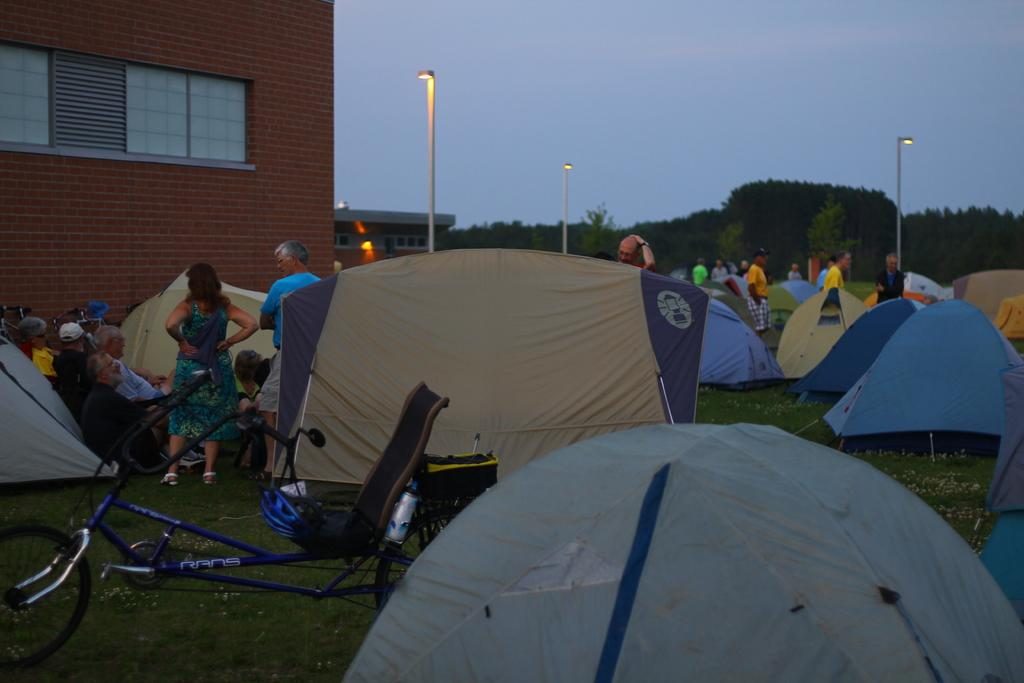How many people are in the image? There are people in the image, but the exact number is not specified. What are some of the people doing in the image? Some of the people are sitting in the image. What type of structures can be seen in the image? There are light poles, tents, and houses in the image. What type of vegetation is present in the image? There are trees in the image. What type of transportation is visible in the image? There is a bicycle in the image. What type of object can be seen for holding liquids? There is a bottle in the image. What part of the natural environment is visible in the image? The sky is visible in the image. What type of picture is hanging on the wall in the image? There is no mention of a picture hanging on the wall in the image. What does the image smell like? The image is a visual representation and does not have a smell. 